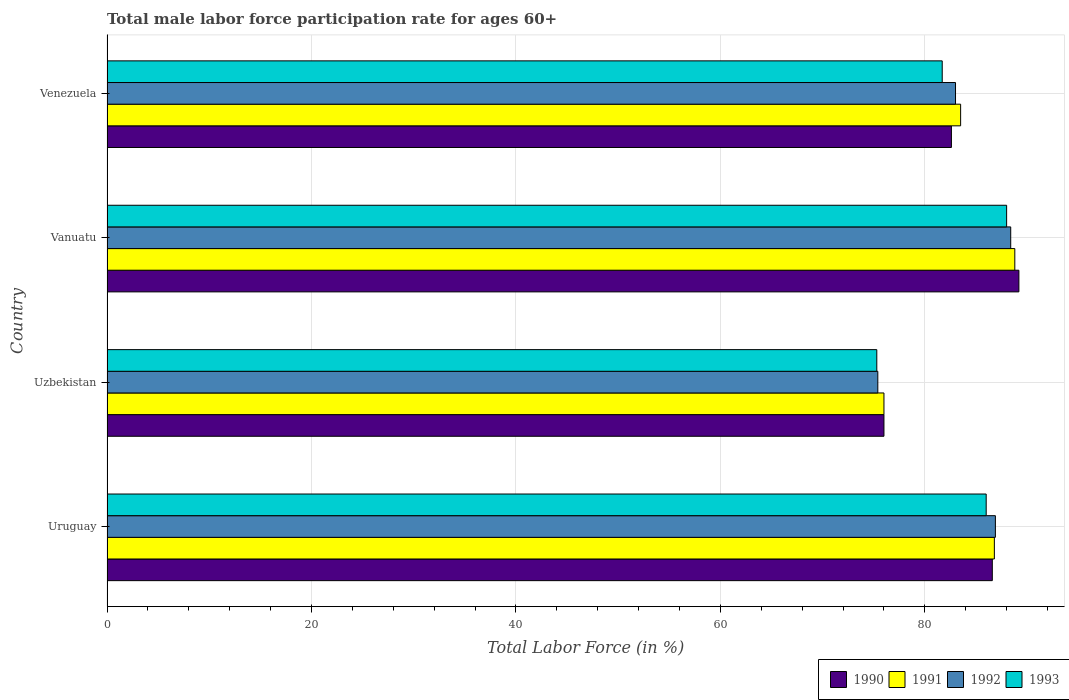How many groups of bars are there?
Your answer should be compact. 4. Are the number of bars on each tick of the Y-axis equal?
Offer a very short reply. Yes. How many bars are there on the 3rd tick from the top?
Offer a very short reply. 4. What is the label of the 4th group of bars from the top?
Keep it short and to the point. Uruguay. What is the male labor force participation rate in 1991 in Uruguay?
Your answer should be very brief. 86.8. Across all countries, what is the maximum male labor force participation rate in 1990?
Give a very brief answer. 89.2. Across all countries, what is the minimum male labor force participation rate in 1993?
Offer a terse response. 75.3. In which country was the male labor force participation rate in 1993 maximum?
Your answer should be compact. Vanuatu. In which country was the male labor force participation rate in 1990 minimum?
Offer a terse response. Uzbekistan. What is the total male labor force participation rate in 1992 in the graph?
Your response must be concise. 333.7. What is the average male labor force participation rate in 1993 per country?
Your answer should be very brief. 82.75. What is the difference between the male labor force participation rate in 1993 and male labor force participation rate in 1991 in Venezuela?
Make the answer very short. -1.8. In how many countries, is the male labor force participation rate in 1990 greater than 52 %?
Ensure brevity in your answer.  4. What is the ratio of the male labor force participation rate in 1990 in Uzbekistan to that in Venezuela?
Provide a succinct answer. 0.92. Is the male labor force participation rate in 1992 in Uzbekistan less than that in Venezuela?
Your response must be concise. Yes. What is the difference between the highest and the second highest male labor force participation rate in 1992?
Your answer should be compact. 1.5. What is the difference between the highest and the lowest male labor force participation rate in 1990?
Keep it short and to the point. 13.2. Is the sum of the male labor force participation rate in 1990 in Uzbekistan and Vanuatu greater than the maximum male labor force participation rate in 1991 across all countries?
Offer a terse response. Yes. What does the 3rd bar from the top in Uzbekistan represents?
Your answer should be compact. 1991. Is it the case that in every country, the sum of the male labor force participation rate in 1993 and male labor force participation rate in 1991 is greater than the male labor force participation rate in 1990?
Ensure brevity in your answer.  Yes. How many bars are there?
Offer a terse response. 16. How many countries are there in the graph?
Offer a terse response. 4. Are the values on the major ticks of X-axis written in scientific E-notation?
Give a very brief answer. No. How are the legend labels stacked?
Make the answer very short. Horizontal. What is the title of the graph?
Offer a terse response. Total male labor force participation rate for ages 60+. What is the label or title of the X-axis?
Your response must be concise. Total Labor Force (in %). What is the Total Labor Force (in %) of 1990 in Uruguay?
Offer a terse response. 86.6. What is the Total Labor Force (in %) of 1991 in Uruguay?
Your response must be concise. 86.8. What is the Total Labor Force (in %) in 1992 in Uruguay?
Your response must be concise. 86.9. What is the Total Labor Force (in %) in 1993 in Uruguay?
Offer a very short reply. 86. What is the Total Labor Force (in %) in 1990 in Uzbekistan?
Provide a short and direct response. 76. What is the Total Labor Force (in %) of 1992 in Uzbekistan?
Your response must be concise. 75.4. What is the Total Labor Force (in %) in 1993 in Uzbekistan?
Ensure brevity in your answer.  75.3. What is the Total Labor Force (in %) of 1990 in Vanuatu?
Ensure brevity in your answer.  89.2. What is the Total Labor Force (in %) in 1991 in Vanuatu?
Keep it short and to the point. 88.8. What is the Total Labor Force (in %) in 1992 in Vanuatu?
Offer a very short reply. 88.4. What is the Total Labor Force (in %) of 1993 in Vanuatu?
Provide a short and direct response. 88. What is the Total Labor Force (in %) of 1990 in Venezuela?
Give a very brief answer. 82.6. What is the Total Labor Force (in %) of 1991 in Venezuela?
Keep it short and to the point. 83.5. What is the Total Labor Force (in %) in 1993 in Venezuela?
Your answer should be compact. 81.7. Across all countries, what is the maximum Total Labor Force (in %) in 1990?
Provide a short and direct response. 89.2. Across all countries, what is the maximum Total Labor Force (in %) in 1991?
Offer a terse response. 88.8. Across all countries, what is the maximum Total Labor Force (in %) in 1992?
Make the answer very short. 88.4. Across all countries, what is the minimum Total Labor Force (in %) in 1991?
Give a very brief answer. 76. Across all countries, what is the minimum Total Labor Force (in %) in 1992?
Keep it short and to the point. 75.4. Across all countries, what is the minimum Total Labor Force (in %) of 1993?
Offer a very short reply. 75.3. What is the total Total Labor Force (in %) of 1990 in the graph?
Your answer should be very brief. 334.4. What is the total Total Labor Force (in %) in 1991 in the graph?
Your response must be concise. 335.1. What is the total Total Labor Force (in %) in 1992 in the graph?
Provide a succinct answer. 333.7. What is the total Total Labor Force (in %) of 1993 in the graph?
Offer a terse response. 331. What is the difference between the Total Labor Force (in %) of 1992 in Uruguay and that in Uzbekistan?
Offer a very short reply. 11.5. What is the difference between the Total Labor Force (in %) in 1991 in Uruguay and that in Vanuatu?
Your response must be concise. -2. What is the difference between the Total Labor Force (in %) of 1993 in Uruguay and that in Vanuatu?
Provide a short and direct response. -2. What is the difference between the Total Labor Force (in %) in 1990 in Uruguay and that in Venezuela?
Keep it short and to the point. 4. What is the difference between the Total Labor Force (in %) of 1991 in Uruguay and that in Venezuela?
Give a very brief answer. 3.3. What is the difference between the Total Labor Force (in %) of 1992 in Uruguay and that in Venezuela?
Your answer should be compact. 3.9. What is the difference between the Total Labor Force (in %) in 1993 in Uruguay and that in Venezuela?
Keep it short and to the point. 4.3. What is the difference between the Total Labor Force (in %) in 1990 in Uzbekistan and that in Vanuatu?
Keep it short and to the point. -13.2. What is the difference between the Total Labor Force (in %) in 1991 in Uzbekistan and that in Venezuela?
Provide a succinct answer. -7.5. What is the difference between the Total Labor Force (in %) of 1992 in Uzbekistan and that in Venezuela?
Ensure brevity in your answer.  -7.6. What is the difference between the Total Labor Force (in %) of 1993 in Uzbekistan and that in Venezuela?
Keep it short and to the point. -6.4. What is the difference between the Total Labor Force (in %) of 1991 in Vanuatu and that in Venezuela?
Keep it short and to the point. 5.3. What is the difference between the Total Labor Force (in %) in 1992 in Vanuatu and that in Venezuela?
Offer a terse response. 5.4. What is the difference between the Total Labor Force (in %) of 1990 in Uruguay and the Total Labor Force (in %) of 1992 in Uzbekistan?
Provide a short and direct response. 11.2. What is the difference between the Total Labor Force (in %) in 1990 in Uruguay and the Total Labor Force (in %) in 1992 in Vanuatu?
Your answer should be very brief. -1.8. What is the difference between the Total Labor Force (in %) in 1990 in Uruguay and the Total Labor Force (in %) in 1993 in Vanuatu?
Keep it short and to the point. -1.4. What is the difference between the Total Labor Force (in %) in 1991 in Uruguay and the Total Labor Force (in %) in 1992 in Vanuatu?
Offer a very short reply. -1.6. What is the difference between the Total Labor Force (in %) of 1991 in Uruguay and the Total Labor Force (in %) of 1993 in Vanuatu?
Your response must be concise. -1.2. What is the difference between the Total Labor Force (in %) in 1992 in Uruguay and the Total Labor Force (in %) in 1993 in Vanuatu?
Provide a succinct answer. -1.1. What is the difference between the Total Labor Force (in %) of 1990 in Uruguay and the Total Labor Force (in %) of 1991 in Venezuela?
Provide a succinct answer. 3.1. What is the difference between the Total Labor Force (in %) of 1990 in Uruguay and the Total Labor Force (in %) of 1992 in Venezuela?
Offer a very short reply. 3.6. What is the difference between the Total Labor Force (in %) in 1990 in Uruguay and the Total Labor Force (in %) in 1993 in Venezuela?
Provide a short and direct response. 4.9. What is the difference between the Total Labor Force (in %) in 1991 in Uruguay and the Total Labor Force (in %) in 1992 in Venezuela?
Provide a short and direct response. 3.8. What is the difference between the Total Labor Force (in %) of 1991 in Uruguay and the Total Labor Force (in %) of 1993 in Venezuela?
Give a very brief answer. 5.1. What is the difference between the Total Labor Force (in %) in 1990 in Uzbekistan and the Total Labor Force (in %) in 1991 in Vanuatu?
Offer a terse response. -12.8. What is the difference between the Total Labor Force (in %) in 1990 in Uzbekistan and the Total Labor Force (in %) in 1992 in Vanuatu?
Keep it short and to the point. -12.4. What is the difference between the Total Labor Force (in %) of 1990 in Uzbekistan and the Total Labor Force (in %) of 1993 in Vanuatu?
Your answer should be very brief. -12. What is the difference between the Total Labor Force (in %) of 1991 in Uzbekistan and the Total Labor Force (in %) of 1993 in Vanuatu?
Your answer should be compact. -12. What is the difference between the Total Labor Force (in %) of 1992 in Uzbekistan and the Total Labor Force (in %) of 1993 in Vanuatu?
Offer a very short reply. -12.6. What is the difference between the Total Labor Force (in %) in 1990 in Uzbekistan and the Total Labor Force (in %) in 1991 in Venezuela?
Keep it short and to the point. -7.5. What is the difference between the Total Labor Force (in %) in 1990 in Uzbekistan and the Total Labor Force (in %) in 1992 in Venezuela?
Offer a very short reply. -7. What is the difference between the Total Labor Force (in %) of 1990 in Uzbekistan and the Total Labor Force (in %) of 1993 in Venezuela?
Keep it short and to the point. -5.7. What is the difference between the Total Labor Force (in %) of 1992 in Uzbekistan and the Total Labor Force (in %) of 1993 in Venezuela?
Your answer should be compact. -6.3. What is the difference between the Total Labor Force (in %) in 1990 in Vanuatu and the Total Labor Force (in %) in 1991 in Venezuela?
Your answer should be very brief. 5.7. What is the difference between the Total Labor Force (in %) in 1991 in Vanuatu and the Total Labor Force (in %) in 1992 in Venezuela?
Provide a succinct answer. 5.8. What is the average Total Labor Force (in %) of 1990 per country?
Ensure brevity in your answer.  83.6. What is the average Total Labor Force (in %) in 1991 per country?
Provide a succinct answer. 83.78. What is the average Total Labor Force (in %) of 1992 per country?
Your answer should be very brief. 83.42. What is the average Total Labor Force (in %) in 1993 per country?
Offer a very short reply. 82.75. What is the difference between the Total Labor Force (in %) of 1991 and Total Labor Force (in %) of 1993 in Uruguay?
Offer a very short reply. 0.8. What is the difference between the Total Labor Force (in %) in 1990 and Total Labor Force (in %) in 1993 in Uzbekistan?
Make the answer very short. 0.7. What is the difference between the Total Labor Force (in %) of 1991 and Total Labor Force (in %) of 1992 in Uzbekistan?
Offer a terse response. 0.6. What is the difference between the Total Labor Force (in %) in 1992 and Total Labor Force (in %) in 1993 in Uzbekistan?
Make the answer very short. 0.1. What is the difference between the Total Labor Force (in %) of 1990 and Total Labor Force (in %) of 1992 in Vanuatu?
Provide a short and direct response. 0.8. What is the difference between the Total Labor Force (in %) of 1990 and Total Labor Force (in %) of 1993 in Vanuatu?
Keep it short and to the point. 1.2. What is the difference between the Total Labor Force (in %) in 1990 and Total Labor Force (in %) in 1992 in Venezuela?
Give a very brief answer. -0.4. What is the difference between the Total Labor Force (in %) of 1992 and Total Labor Force (in %) of 1993 in Venezuela?
Give a very brief answer. 1.3. What is the ratio of the Total Labor Force (in %) of 1990 in Uruguay to that in Uzbekistan?
Your response must be concise. 1.14. What is the ratio of the Total Labor Force (in %) of 1991 in Uruguay to that in Uzbekistan?
Your answer should be compact. 1.14. What is the ratio of the Total Labor Force (in %) of 1992 in Uruguay to that in Uzbekistan?
Your response must be concise. 1.15. What is the ratio of the Total Labor Force (in %) of 1993 in Uruguay to that in Uzbekistan?
Your response must be concise. 1.14. What is the ratio of the Total Labor Force (in %) in 1990 in Uruguay to that in Vanuatu?
Your answer should be very brief. 0.97. What is the ratio of the Total Labor Force (in %) in 1991 in Uruguay to that in Vanuatu?
Your answer should be very brief. 0.98. What is the ratio of the Total Labor Force (in %) in 1992 in Uruguay to that in Vanuatu?
Make the answer very short. 0.98. What is the ratio of the Total Labor Force (in %) of 1993 in Uruguay to that in Vanuatu?
Your answer should be very brief. 0.98. What is the ratio of the Total Labor Force (in %) of 1990 in Uruguay to that in Venezuela?
Keep it short and to the point. 1.05. What is the ratio of the Total Labor Force (in %) of 1991 in Uruguay to that in Venezuela?
Your response must be concise. 1.04. What is the ratio of the Total Labor Force (in %) of 1992 in Uruguay to that in Venezuela?
Provide a succinct answer. 1.05. What is the ratio of the Total Labor Force (in %) in 1993 in Uruguay to that in Venezuela?
Your answer should be very brief. 1.05. What is the ratio of the Total Labor Force (in %) of 1990 in Uzbekistan to that in Vanuatu?
Keep it short and to the point. 0.85. What is the ratio of the Total Labor Force (in %) of 1991 in Uzbekistan to that in Vanuatu?
Provide a short and direct response. 0.86. What is the ratio of the Total Labor Force (in %) of 1992 in Uzbekistan to that in Vanuatu?
Offer a terse response. 0.85. What is the ratio of the Total Labor Force (in %) in 1993 in Uzbekistan to that in Vanuatu?
Provide a succinct answer. 0.86. What is the ratio of the Total Labor Force (in %) in 1990 in Uzbekistan to that in Venezuela?
Keep it short and to the point. 0.92. What is the ratio of the Total Labor Force (in %) of 1991 in Uzbekistan to that in Venezuela?
Your response must be concise. 0.91. What is the ratio of the Total Labor Force (in %) of 1992 in Uzbekistan to that in Venezuela?
Offer a terse response. 0.91. What is the ratio of the Total Labor Force (in %) of 1993 in Uzbekistan to that in Venezuela?
Give a very brief answer. 0.92. What is the ratio of the Total Labor Force (in %) in 1990 in Vanuatu to that in Venezuela?
Your response must be concise. 1.08. What is the ratio of the Total Labor Force (in %) of 1991 in Vanuatu to that in Venezuela?
Your response must be concise. 1.06. What is the ratio of the Total Labor Force (in %) of 1992 in Vanuatu to that in Venezuela?
Offer a terse response. 1.07. What is the ratio of the Total Labor Force (in %) of 1993 in Vanuatu to that in Venezuela?
Provide a succinct answer. 1.08. What is the difference between the highest and the second highest Total Labor Force (in %) in 1990?
Your answer should be compact. 2.6. What is the difference between the highest and the second highest Total Labor Force (in %) of 1991?
Offer a terse response. 2. What is the difference between the highest and the second highest Total Labor Force (in %) in 1993?
Your answer should be compact. 2. What is the difference between the highest and the lowest Total Labor Force (in %) of 1991?
Ensure brevity in your answer.  12.8. What is the difference between the highest and the lowest Total Labor Force (in %) of 1992?
Your response must be concise. 13. What is the difference between the highest and the lowest Total Labor Force (in %) in 1993?
Your response must be concise. 12.7. 